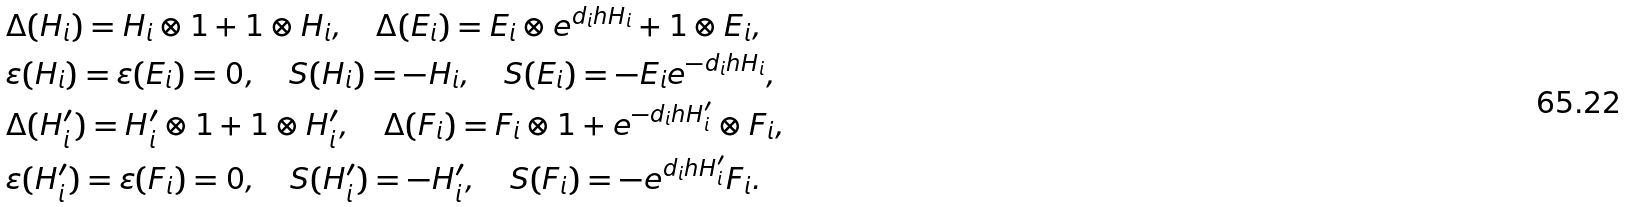Convert formula to latex. <formula><loc_0><loc_0><loc_500><loc_500>& \Delta ( H _ { i } ) = H _ { i } \otimes 1 + 1 \otimes H _ { i } , \quad \Delta ( E _ { i } ) = E _ { i } \otimes e ^ { d _ { i } h H _ { i } } + 1 \otimes E _ { i } , \\ & \varepsilon ( H _ { i } ) = \varepsilon ( E _ { i } ) = 0 , \quad S ( H _ { i } ) = - H _ { i } , \quad S ( E _ { i } ) = - E _ { i } e ^ { - d _ { i } h H _ { i } } , \\ & \Delta ( H ^ { \prime } _ { i } ) = H ^ { \prime } _ { i } \otimes 1 + 1 \otimes H ^ { \prime } _ { i } , \quad \Delta ( F _ { i } ) = F _ { i } \otimes 1 + e ^ { - d _ { i } h H ^ { \prime } _ { i } } \otimes F _ { i } , \\ & \varepsilon ( H ^ { \prime } _ { i } ) = \varepsilon ( F _ { i } ) = 0 , \quad S ( H ^ { \prime } _ { i } ) = - H ^ { \prime } _ { i } , \quad S ( F _ { i } ) = - e ^ { d _ { i } h H ^ { \prime } _ { i } } F _ { i } .</formula> 